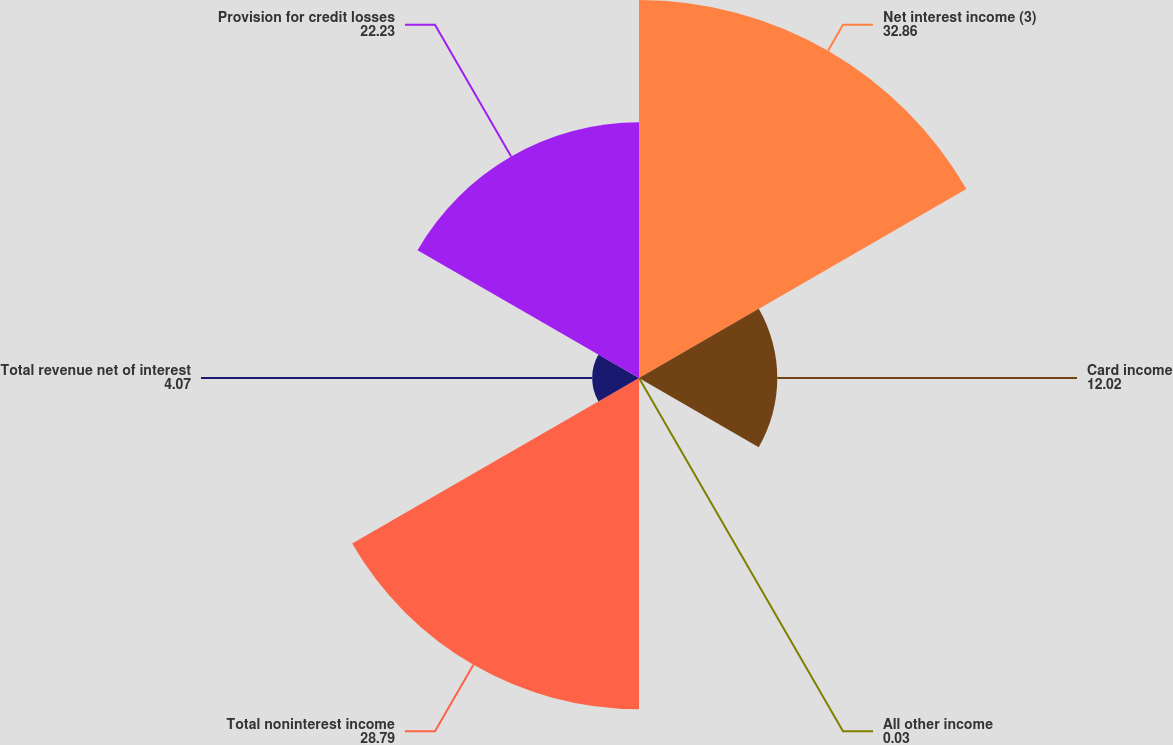Convert chart to OTSL. <chart><loc_0><loc_0><loc_500><loc_500><pie_chart><fcel>Net interest income (3)<fcel>Card income<fcel>All other income<fcel>Total noninterest income<fcel>Total revenue net of interest<fcel>Provision for credit losses<nl><fcel>32.86%<fcel>12.02%<fcel>0.03%<fcel>28.79%<fcel>4.07%<fcel>22.23%<nl></chart> 